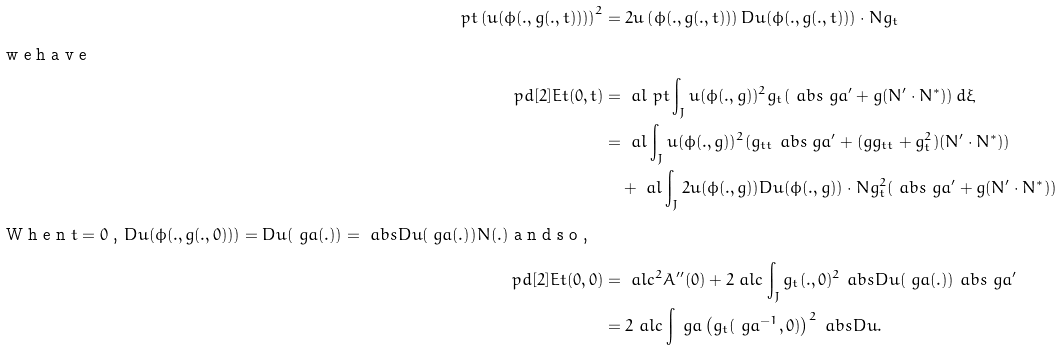Convert formula to latex. <formula><loc_0><loc_0><loc_500><loc_500>\ p { t } \left ( u ( \phi ( . , g ( . , t ) ) ) \right ) ^ { 2 } & = 2 u \left ( \phi ( . , g ( . , t ) ) \right ) D u ( \phi ( . , g ( . , t ) ) ) \cdot N g _ { t } \\ \intertext { w e h a v e } \ p d [ 2 ] { E } { t } ( 0 , t ) & = \ a l \ p { t } \int _ { J } u ( \phi ( . , g ) ) ^ { 2 } g _ { t } ( \ a b s { \ g a ^ { \prime } } + g ( N ^ { \prime } \cdot N ^ { * } ) ) \, d \xi \\ & = \ a l \int _ { J } u ( \phi ( . , g ) ) ^ { 2 } ( g _ { t t } \ a b s { \ g a ^ { \prime } } + ( g g _ { t t } + g _ { t } ^ { 2 } ) ( N ^ { \prime } \cdot N ^ { * } ) ) \\ & \quad + \ a l \int _ { J } 2 u ( \phi ( . , g ) ) D u ( \phi ( . , g ) ) \cdot N g _ { t } ^ { 2 } ( \ a b s { \ g a ^ { \prime } } + g ( N ^ { \prime } \cdot N ^ { * } ) ) \\ \intertext { W h e n $ t = 0 $ , $ D u ( \phi ( . , g ( . , 0 ) ) ) = D u ( \ g a ( . ) ) = \ a b s { D u ( \ g a ( . ) ) } N ( . ) $ a n d s o , } \ p d [ 2 ] { E } { t } ( 0 , 0 ) & = \ a l c ^ { 2 } A ^ { \prime \prime } ( 0 ) + 2 \ a l c \int _ { J } g _ { t } ( . , 0 ) ^ { 2 } \ a b s { D u ( \ g a ( . ) ) } \ a b s { \ g a ^ { \prime } } \\ & = 2 \ a l c \int _ { \ } g a \left ( g _ { t } ( \ g a ^ { - 1 } , 0 ) \right ) ^ { 2 } \ a b s { D u } .</formula> 